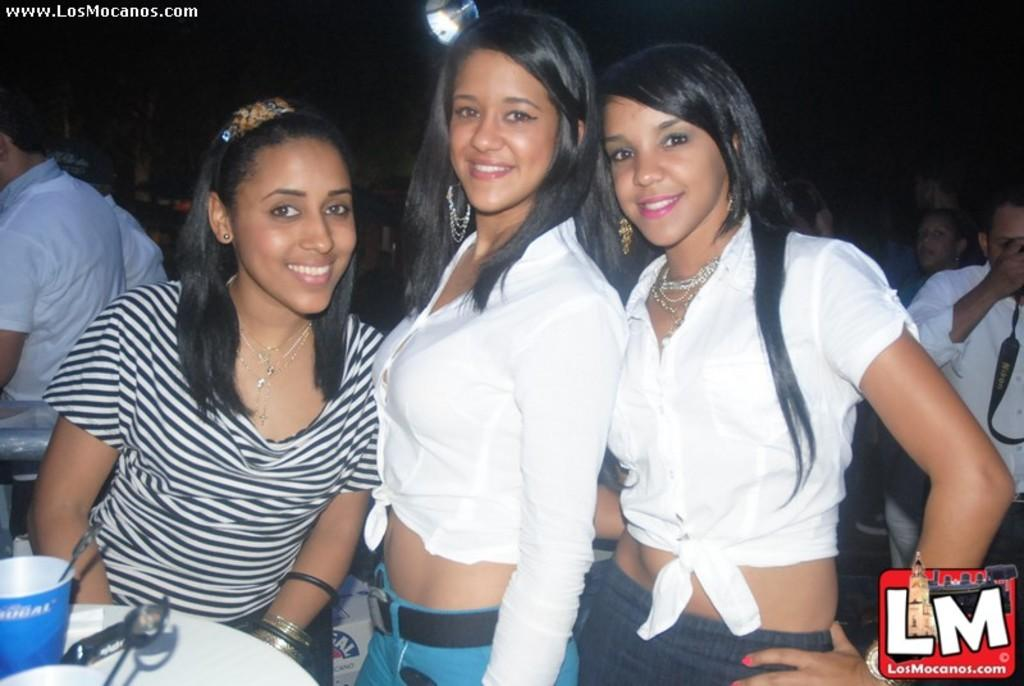<image>
Relay a brief, clear account of the picture shown. Three girls pose for a picture on Losmocanos.com 